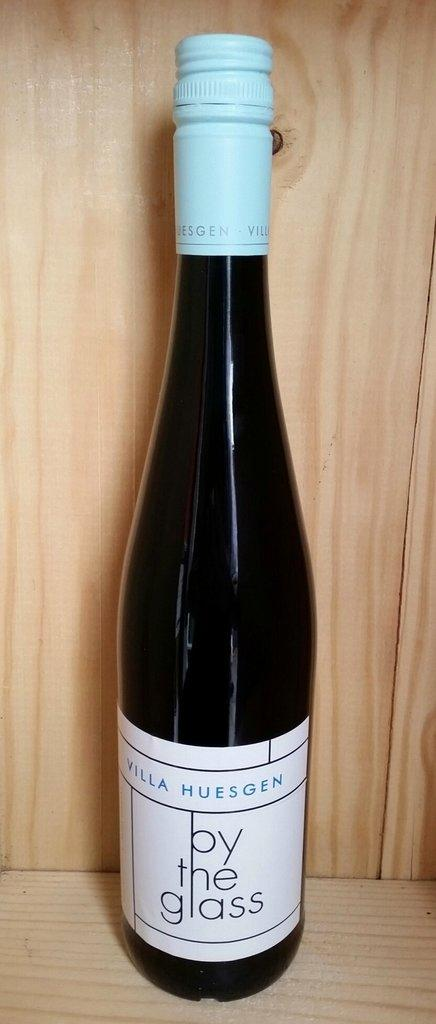What object can be seen in the image? There is a bottle in the image. What is written or printed on the bottle? The bottle has text on it. Where is the bottle located in the image? The bottle is placed on a surface that resembles a table. Can you see any wilderness or forests in the image? There is no wilderness or forest present in the image; it only features a bottle on a surface. How many feet are visible in the image? There are no feet visible in the image; it only features a bottle on a surface. 